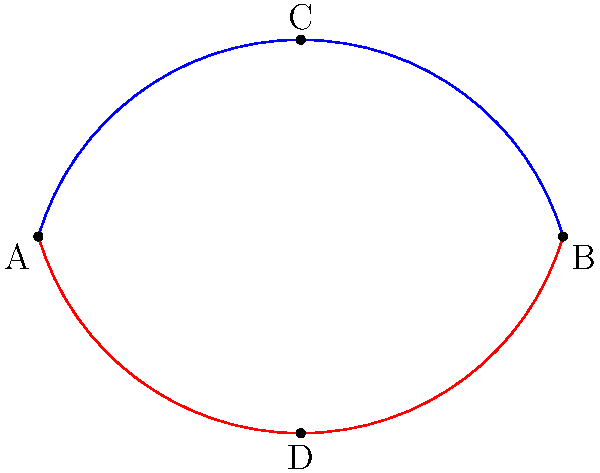In the hyperbolic pattern shown above, which is commonly found in traditional textile designs, what is the relationship between the lines AC and BD? To understand the relationship between lines AC and BD in this hyperbolic pattern, let's follow these steps:

1. Observe the shape: The diagram shows two intersecting curves forming a hyperbolic pattern.

2. Identify the lines:
   - Line AC (blue) extends from point A through C to the opposite side.
   - Line BD (red) extends from point B through D to the opposite side.

3. Analyze the intersection:
   - Lines AC and BD intersect at two points: one above and one below the horizontal axis.

4. Consider the hyperbolic geometry:
   - In hyperbolic geometry, parallel lines can diverge and never intersect.
   - However, these lines clearly intersect, so they are not parallel.

5. Examine the angle of intersection:
   - The lines appear to intersect at right angles at both intersection points.

6. Apply knowledge of hyperbolic geometry:
   - In hyperbolic geometry, lines that intersect at right angles are called orthogonal.

Therefore, based on this analysis, we can conclude that lines AC and BD are orthogonal in this hyperbolic pattern.
Answer: Orthogonal 